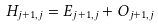<formula> <loc_0><loc_0><loc_500><loc_500>H _ { j + 1 , j } = E _ { j + 1 , j } + { O } _ { j + 1 , j }</formula> 